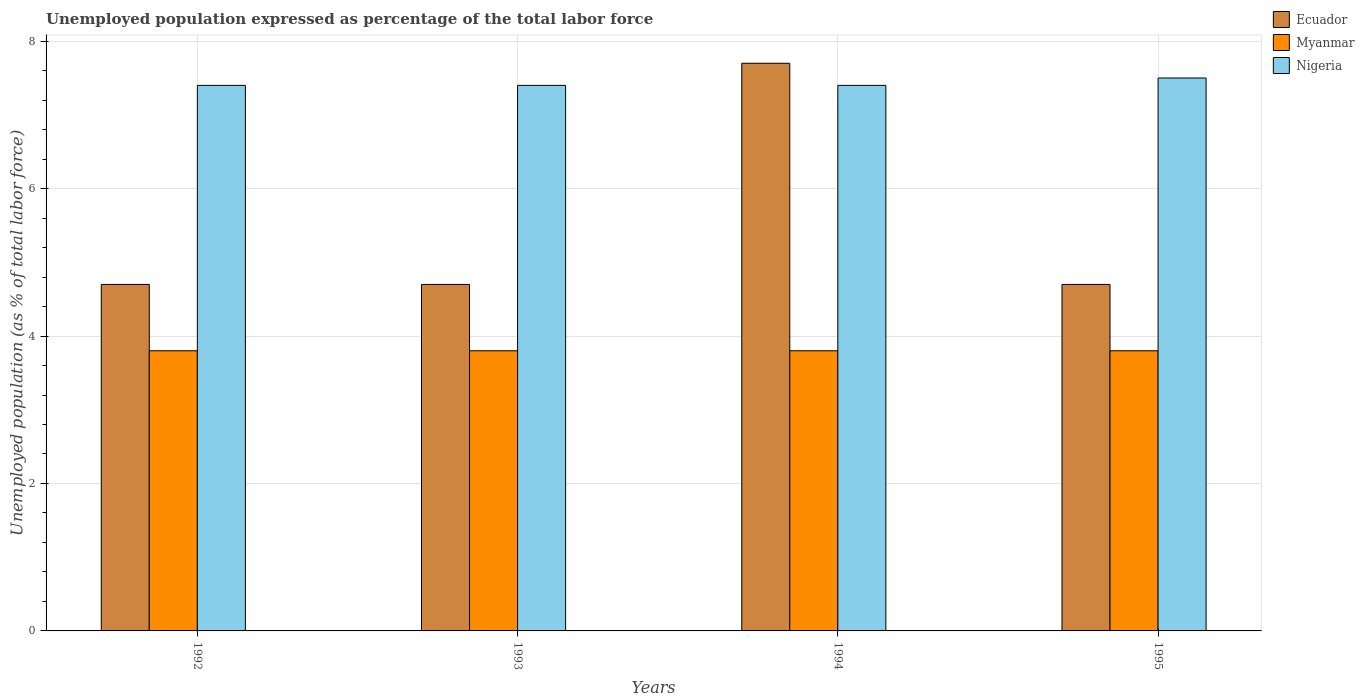Are the number of bars per tick equal to the number of legend labels?
Keep it short and to the point. Yes. How many bars are there on the 1st tick from the left?
Provide a succinct answer. 3. How many bars are there on the 1st tick from the right?
Give a very brief answer. 3. In how many cases, is the number of bars for a given year not equal to the number of legend labels?
Offer a terse response. 0. What is the unemployment in in Nigeria in 1994?
Your answer should be compact. 7.4. Across all years, what is the maximum unemployment in in Myanmar?
Make the answer very short. 3.8. Across all years, what is the minimum unemployment in in Nigeria?
Give a very brief answer. 7.4. What is the total unemployment in in Ecuador in the graph?
Give a very brief answer. 21.8. What is the difference between the unemployment in in Ecuador in 1992 and that in 1995?
Your response must be concise. 0. What is the difference between the unemployment in in Myanmar in 1992 and the unemployment in in Nigeria in 1995?
Provide a succinct answer. -3.7. What is the average unemployment in in Myanmar per year?
Make the answer very short. 3.8. In the year 1994, what is the difference between the unemployment in in Myanmar and unemployment in in Ecuador?
Offer a very short reply. -3.9. In how many years, is the unemployment in in Nigeria greater than 7.2 %?
Make the answer very short. 4. Is the difference between the unemployment in in Myanmar in 1992 and 1995 greater than the difference between the unemployment in in Ecuador in 1992 and 1995?
Keep it short and to the point. No. What is the difference between the highest and the second highest unemployment in in Ecuador?
Offer a terse response. 3. What is the difference between the highest and the lowest unemployment in in Ecuador?
Ensure brevity in your answer.  3. In how many years, is the unemployment in in Nigeria greater than the average unemployment in in Nigeria taken over all years?
Provide a succinct answer. 1. What does the 3rd bar from the left in 1993 represents?
Provide a succinct answer. Nigeria. What does the 1st bar from the right in 1993 represents?
Give a very brief answer. Nigeria. Is it the case that in every year, the sum of the unemployment in in Nigeria and unemployment in in Ecuador is greater than the unemployment in in Myanmar?
Provide a succinct answer. Yes. How many bars are there?
Provide a short and direct response. 12. What is the difference between two consecutive major ticks on the Y-axis?
Offer a terse response. 2. Are the values on the major ticks of Y-axis written in scientific E-notation?
Your answer should be compact. No. Does the graph contain grids?
Your answer should be very brief. Yes. Where does the legend appear in the graph?
Offer a terse response. Top right. How are the legend labels stacked?
Offer a very short reply. Vertical. What is the title of the graph?
Your answer should be compact. Unemployed population expressed as percentage of the total labor force. What is the label or title of the X-axis?
Provide a succinct answer. Years. What is the label or title of the Y-axis?
Give a very brief answer. Unemployed population (as % of total labor force). What is the Unemployed population (as % of total labor force) of Ecuador in 1992?
Keep it short and to the point. 4.7. What is the Unemployed population (as % of total labor force) of Myanmar in 1992?
Provide a succinct answer. 3.8. What is the Unemployed population (as % of total labor force) in Nigeria in 1992?
Give a very brief answer. 7.4. What is the Unemployed population (as % of total labor force) of Ecuador in 1993?
Your answer should be compact. 4.7. What is the Unemployed population (as % of total labor force) of Myanmar in 1993?
Provide a short and direct response. 3.8. What is the Unemployed population (as % of total labor force) of Nigeria in 1993?
Give a very brief answer. 7.4. What is the Unemployed population (as % of total labor force) of Ecuador in 1994?
Your response must be concise. 7.7. What is the Unemployed population (as % of total labor force) in Myanmar in 1994?
Your answer should be very brief. 3.8. What is the Unemployed population (as % of total labor force) of Nigeria in 1994?
Give a very brief answer. 7.4. What is the Unemployed population (as % of total labor force) in Ecuador in 1995?
Offer a very short reply. 4.7. What is the Unemployed population (as % of total labor force) of Myanmar in 1995?
Your response must be concise. 3.8. Across all years, what is the maximum Unemployed population (as % of total labor force) of Ecuador?
Keep it short and to the point. 7.7. Across all years, what is the maximum Unemployed population (as % of total labor force) in Myanmar?
Keep it short and to the point. 3.8. Across all years, what is the maximum Unemployed population (as % of total labor force) in Nigeria?
Ensure brevity in your answer.  7.5. Across all years, what is the minimum Unemployed population (as % of total labor force) of Ecuador?
Your answer should be compact. 4.7. Across all years, what is the minimum Unemployed population (as % of total labor force) of Myanmar?
Make the answer very short. 3.8. Across all years, what is the minimum Unemployed population (as % of total labor force) in Nigeria?
Give a very brief answer. 7.4. What is the total Unemployed population (as % of total labor force) in Ecuador in the graph?
Make the answer very short. 21.8. What is the total Unemployed population (as % of total labor force) in Myanmar in the graph?
Your answer should be very brief. 15.2. What is the total Unemployed population (as % of total labor force) of Nigeria in the graph?
Make the answer very short. 29.7. What is the difference between the Unemployed population (as % of total labor force) of Myanmar in 1992 and that in 1993?
Your response must be concise. 0. What is the difference between the Unemployed population (as % of total labor force) in Nigeria in 1992 and that in 1993?
Offer a terse response. 0. What is the difference between the Unemployed population (as % of total labor force) of Myanmar in 1992 and that in 1994?
Provide a succinct answer. 0. What is the difference between the Unemployed population (as % of total labor force) in Ecuador in 1992 and that in 1995?
Your answer should be very brief. 0. What is the difference between the Unemployed population (as % of total labor force) of Nigeria in 1992 and that in 1995?
Offer a terse response. -0.1. What is the difference between the Unemployed population (as % of total labor force) of Ecuador in 1993 and that in 1994?
Provide a short and direct response. -3. What is the difference between the Unemployed population (as % of total labor force) of Myanmar in 1993 and that in 1994?
Keep it short and to the point. 0. What is the difference between the Unemployed population (as % of total labor force) in Nigeria in 1993 and that in 1994?
Keep it short and to the point. 0. What is the difference between the Unemployed population (as % of total labor force) in Ecuador in 1993 and that in 1995?
Ensure brevity in your answer.  0. What is the difference between the Unemployed population (as % of total labor force) of Nigeria in 1994 and that in 1995?
Offer a terse response. -0.1. What is the difference between the Unemployed population (as % of total labor force) in Ecuador in 1992 and the Unemployed population (as % of total labor force) in Myanmar in 1993?
Make the answer very short. 0.9. What is the difference between the Unemployed population (as % of total labor force) of Ecuador in 1992 and the Unemployed population (as % of total labor force) of Nigeria in 1993?
Your answer should be very brief. -2.7. What is the difference between the Unemployed population (as % of total labor force) of Ecuador in 1992 and the Unemployed population (as % of total labor force) of Nigeria in 1994?
Your response must be concise. -2.7. What is the difference between the Unemployed population (as % of total labor force) of Myanmar in 1992 and the Unemployed population (as % of total labor force) of Nigeria in 1994?
Offer a very short reply. -3.6. What is the difference between the Unemployed population (as % of total labor force) of Ecuador in 1992 and the Unemployed population (as % of total labor force) of Nigeria in 1995?
Keep it short and to the point. -2.8. What is the difference between the Unemployed population (as % of total labor force) in Myanmar in 1992 and the Unemployed population (as % of total labor force) in Nigeria in 1995?
Your response must be concise. -3.7. What is the difference between the Unemployed population (as % of total labor force) of Ecuador in 1993 and the Unemployed population (as % of total labor force) of Myanmar in 1994?
Make the answer very short. 0.9. What is the difference between the Unemployed population (as % of total labor force) of Ecuador in 1993 and the Unemployed population (as % of total labor force) of Nigeria in 1994?
Offer a very short reply. -2.7. What is the difference between the Unemployed population (as % of total labor force) of Ecuador in 1993 and the Unemployed population (as % of total labor force) of Nigeria in 1995?
Your answer should be very brief. -2.8. What is the difference between the Unemployed population (as % of total labor force) of Ecuador in 1994 and the Unemployed population (as % of total labor force) of Myanmar in 1995?
Your response must be concise. 3.9. What is the difference between the Unemployed population (as % of total labor force) of Ecuador in 1994 and the Unemployed population (as % of total labor force) of Nigeria in 1995?
Offer a terse response. 0.2. What is the average Unemployed population (as % of total labor force) of Ecuador per year?
Give a very brief answer. 5.45. What is the average Unemployed population (as % of total labor force) of Nigeria per year?
Give a very brief answer. 7.42. In the year 1992, what is the difference between the Unemployed population (as % of total labor force) in Ecuador and Unemployed population (as % of total labor force) in Myanmar?
Give a very brief answer. 0.9. In the year 1992, what is the difference between the Unemployed population (as % of total labor force) in Ecuador and Unemployed population (as % of total labor force) in Nigeria?
Give a very brief answer. -2.7. In the year 1992, what is the difference between the Unemployed population (as % of total labor force) in Myanmar and Unemployed population (as % of total labor force) in Nigeria?
Offer a terse response. -3.6. In the year 1993, what is the difference between the Unemployed population (as % of total labor force) in Ecuador and Unemployed population (as % of total labor force) in Myanmar?
Give a very brief answer. 0.9. In the year 1993, what is the difference between the Unemployed population (as % of total labor force) of Myanmar and Unemployed population (as % of total labor force) of Nigeria?
Offer a terse response. -3.6. In the year 1995, what is the difference between the Unemployed population (as % of total labor force) in Ecuador and Unemployed population (as % of total labor force) in Myanmar?
Give a very brief answer. 0.9. In the year 1995, what is the difference between the Unemployed population (as % of total labor force) in Ecuador and Unemployed population (as % of total labor force) in Nigeria?
Provide a succinct answer. -2.8. What is the ratio of the Unemployed population (as % of total labor force) in Ecuador in 1992 to that in 1993?
Make the answer very short. 1. What is the ratio of the Unemployed population (as % of total labor force) in Myanmar in 1992 to that in 1993?
Give a very brief answer. 1. What is the ratio of the Unemployed population (as % of total labor force) of Nigeria in 1992 to that in 1993?
Give a very brief answer. 1. What is the ratio of the Unemployed population (as % of total labor force) in Ecuador in 1992 to that in 1994?
Offer a terse response. 0.61. What is the ratio of the Unemployed population (as % of total labor force) of Myanmar in 1992 to that in 1994?
Give a very brief answer. 1. What is the ratio of the Unemployed population (as % of total labor force) in Ecuador in 1992 to that in 1995?
Ensure brevity in your answer.  1. What is the ratio of the Unemployed population (as % of total labor force) in Myanmar in 1992 to that in 1995?
Provide a short and direct response. 1. What is the ratio of the Unemployed population (as % of total labor force) in Nigeria in 1992 to that in 1995?
Your answer should be compact. 0.99. What is the ratio of the Unemployed population (as % of total labor force) of Ecuador in 1993 to that in 1994?
Provide a short and direct response. 0.61. What is the ratio of the Unemployed population (as % of total labor force) in Nigeria in 1993 to that in 1994?
Make the answer very short. 1. What is the ratio of the Unemployed population (as % of total labor force) in Nigeria in 1993 to that in 1995?
Offer a very short reply. 0.99. What is the ratio of the Unemployed population (as % of total labor force) of Ecuador in 1994 to that in 1995?
Keep it short and to the point. 1.64. What is the ratio of the Unemployed population (as % of total labor force) of Myanmar in 1994 to that in 1995?
Keep it short and to the point. 1. What is the ratio of the Unemployed population (as % of total labor force) of Nigeria in 1994 to that in 1995?
Your response must be concise. 0.99. What is the difference between the highest and the second highest Unemployed population (as % of total labor force) of Myanmar?
Give a very brief answer. 0. 